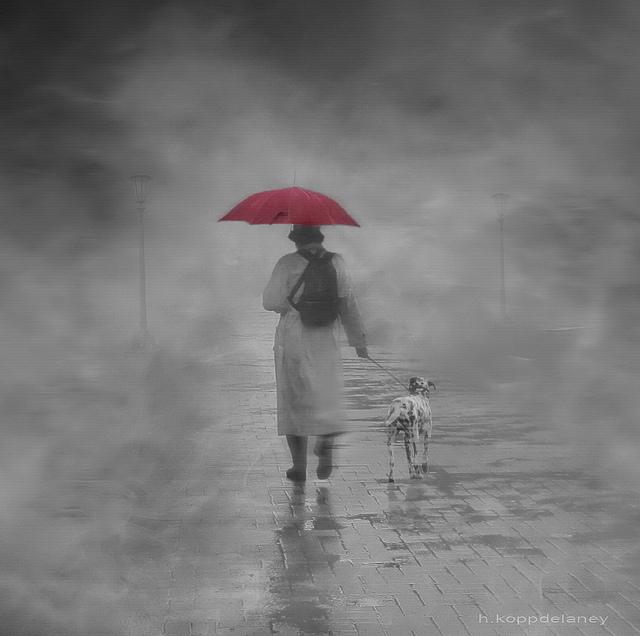What is the lady doing?
Concise answer only. Walking dog. What color is the umbrella?
Concise answer only. Red. Is it raining?
Write a very short answer. Yes. What type of dog is pictured?
Short answer required. Dalmatian. Why is she holding her umbrella so high?
Short answer required. Raining. 